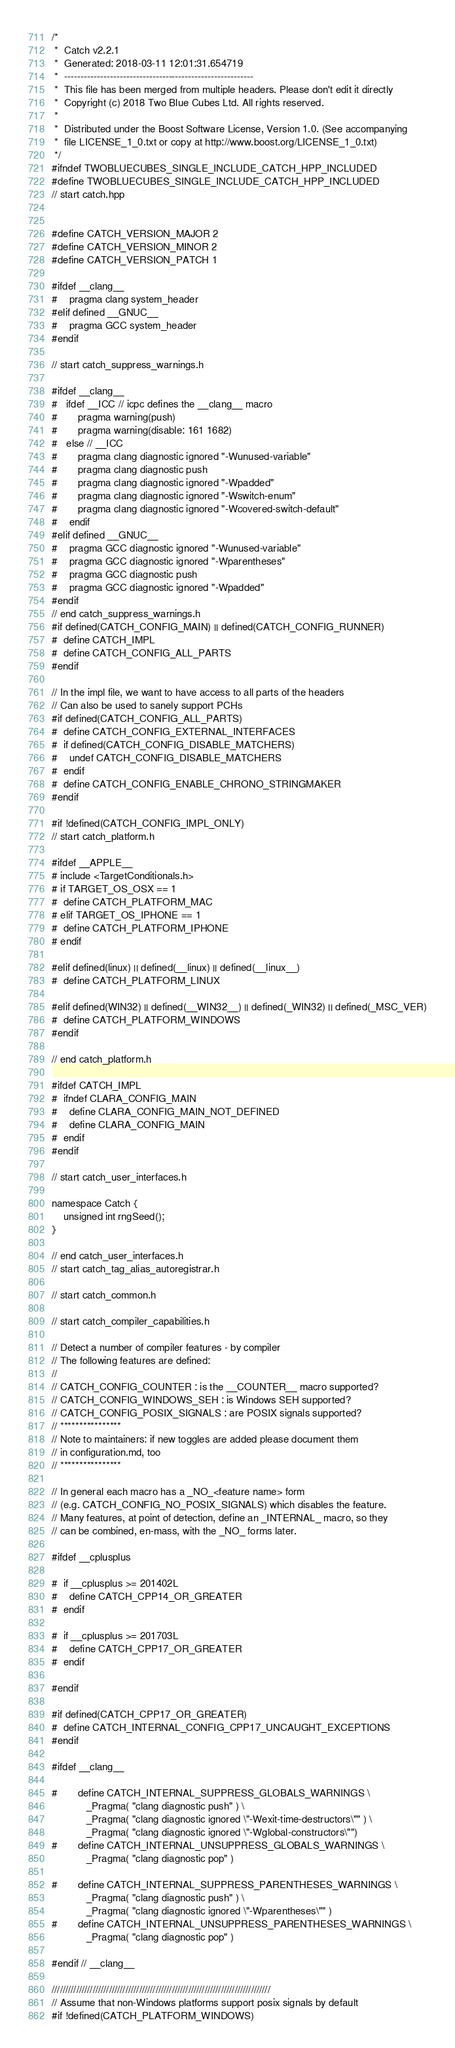<code> <loc_0><loc_0><loc_500><loc_500><_C++_>/*
 *  Catch v2.2.1
 *  Generated: 2018-03-11 12:01:31.654719
 *  ----------------------------------------------------------
 *  This file has been merged from multiple headers. Please don't edit it directly
 *  Copyright (c) 2018 Two Blue Cubes Ltd. All rights reserved.
 *
 *  Distributed under the Boost Software License, Version 1.0. (See accompanying
 *  file LICENSE_1_0.txt or copy at http://www.boost.org/LICENSE_1_0.txt)
 */
#ifndef TWOBLUECUBES_SINGLE_INCLUDE_CATCH_HPP_INCLUDED
#define TWOBLUECUBES_SINGLE_INCLUDE_CATCH_HPP_INCLUDED
// start catch.hpp


#define CATCH_VERSION_MAJOR 2
#define CATCH_VERSION_MINOR 2
#define CATCH_VERSION_PATCH 1

#ifdef __clang__
#    pragma clang system_header
#elif defined __GNUC__
#    pragma GCC system_header
#endif

// start catch_suppress_warnings.h

#ifdef __clang__
#   ifdef __ICC // icpc defines the __clang__ macro
#       pragma warning(push)
#       pragma warning(disable: 161 1682)
#   else // __ICC
#       pragma clang diagnostic ignored "-Wunused-variable"
#       pragma clang diagnostic push
#       pragma clang diagnostic ignored "-Wpadded"
#       pragma clang diagnostic ignored "-Wswitch-enum"
#       pragma clang diagnostic ignored "-Wcovered-switch-default"
#    endif
#elif defined __GNUC__
#    pragma GCC diagnostic ignored "-Wunused-variable"
#    pragma GCC diagnostic ignored "-Wparentheses"
#    pragma GCC diagnostic push
#    pragma GCC diagnostic ignored "-Wpadded"
#endif
// end catch_suppress_warnings.h
#if defined(CATCH_CONFIG_MAIN) || defined(CATCH_CONFIG_RUNNER)
#  define CATCH_IMPL
#  define CATCH_CONFIG_ALL_PARTS
#endif

// In the impl file, we want to have access to all parts of the headers
// Can also be used to sanely support PCHs
#if defined(CATCH_CONFIG_ALL_PARTS)
#  define CATCH_CONFIG_EXTERNAL_INTERFACES
#  if defined(CATCH_CONFIG_DISABLE_MATCHERS)
#    undef CATCH_CONFIG_DISABLE_MATCHERS
#  endif
#  define CATCH_CONFIG_ENABLE_CHRONO_STRINGMAKER
#endif

#if !defined(CATCH_CONFIG_IMPL_ONLY)
// start catch_platform.h

#ifdef __APPLE__
# include <TargetConditionals.h>
# if TARGET_OS_OSX == 1
#  define CATCH_PLATFORM_MAC
# elif TARGET_OS_IPHONE == 1
#  define CATCH_PLATFORM_IPHONE
# endif

#elif defined(linux) || defined(__linux) || defined(__linux__)
#  define CATCH_PLATFORM_LINUX

#elif defined(WIN32) || defined(__WIN32__) || defined(_WIN32) || defined(_MSC_VER)
#  define CATCH_PLATFORM_WINDOWS
#endif

// end catch_platform.h

#ifdef CATCH_IMPL
#  ifndef CLARA_CONFIG_MAIN
#    define CLARA_CONFIG_MAIN_NOT_DEFINED
#    define CLARA_CONFIG_MAIN
#  endif
#endif

// start catch_user_interfaces.h

namespace Catch {
    unsigned int rngSeed();
}

// end catch_user_interfaces.h
// start catch_tag_alias_autoregistrar.h

// start catch_common.h

// start catch_compiler_capabilities.h

// Detect a number of compiler features - by compiler
// The following features are defined:
//
// CATCH_CONFIG_COUNTER : is the __COUNTER__ macro supported?
// CATCH_CONFIG_WINDOWS_SEH : is Windows SEH supported?
// CATCH_CONFIG_POSIX_SIGNALS : are POSIX signals supported?
// ****************
// Note to maintainers: if new toggles are added please document them
// in configuration.md, too
// ****************

// In general each macro has a _NO_<feature name> form
// (e.g. CATCH_CONFIG_NO_POSIX_SIGNALS) which disables the feature.
// Many features, at point of detection, define an _INTERNAL_ macro, so they
// can be combined, en-mass, with the _NO_ forms later.

#ifdef __cplusplus

#  if __cplusplus >= 201402L
#    define CATCH_CPP14_OR_GREATER
#  endif

#  if __cplusplus >= 201703L
#    define CATCH_CPP17_OR_GREATER
#  endif

#endif

#if defined(CATCH_CPP17_OR_GREATER)
#  define CATCH_INTERNAL_CONFIG_CPP17_UNCAUGHT_EXCEPTIONS
#endif

#ifdef __clang__

#       define CATCH_INTERNAL_SUPPRESS_GLOBALS_WARNINGS \
            _Pragma( "clang diagnostic push" ) \
            _Pragma( "clang diagnostic ignored \"-Wexit-time-destructors\"" ) \
            _Pragma( "clang diagnostic ignored \"-Wglobal-constructors\"")
#       define CATCH_INTERNAL_UNSUPPRESS_GLOBALS_WARNINGS \
            _Pragma( "clang diagnostic pop" )

#       define CATCH_INTERNAL_SUPPRESS_PARENTHESES_WARNINGS \
            _Pragma( "clang diagnostic push" ) \
            _Pragma( "clang diagnostic ignored \"-Wparentheses\"" )
#       define CATCH_INTERNAL_UNSUPPRESS_PARENTHESES_WARNINGS \
            _Pragma( "clang diagnostic pop" )

#endif // __clang__

////////////////////////////////////////////////////////////////////////////////
// Assume that non-Windows platforms support posix signals by default
#if !defined(CATCH_PLATFORM_WINDOWS)</code> 